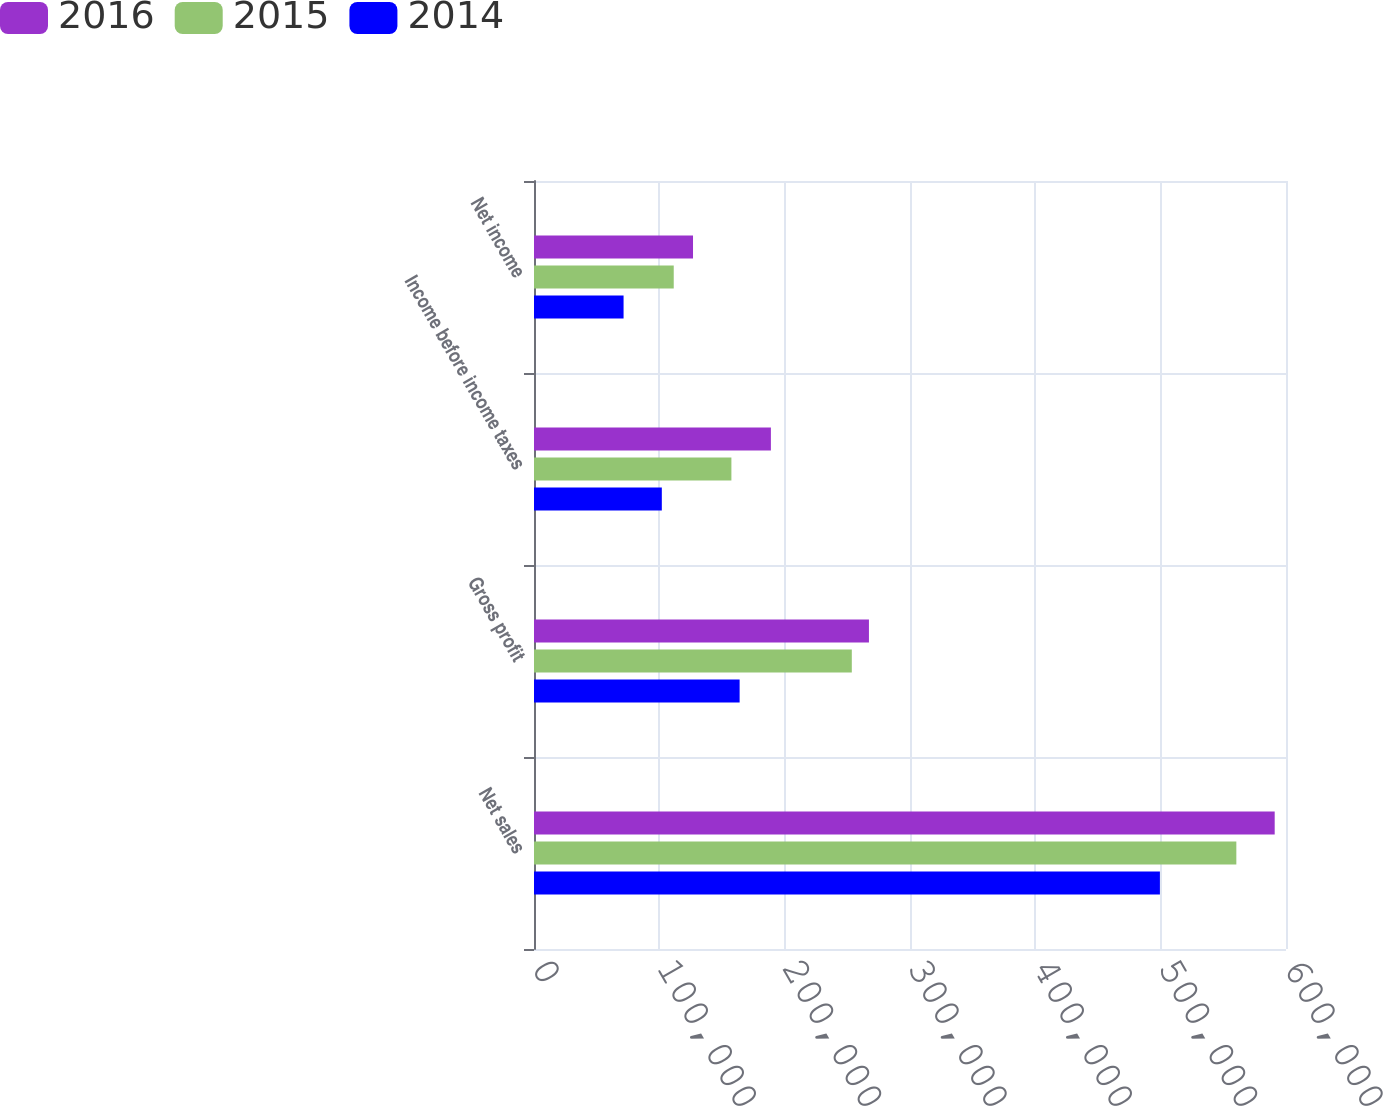<chart> <loc_0><loc_0><loc_500><loc_500><stacked_bar_chart><ecel><fcel>Net sales<fcel>Gross profit<fcel>Income before income taxes<fcel>Net income<nl><fcel>2016<fcel>590980<fcel>267241<fcel>189016<fcel>126872<nl><fcel>2015<fcel>560376<fcel>253569<fcel>157501<fcel>111491<nl><fcel>2014<fcel>499394<fcel>164063<fcel>101983<fcel>71466<nl></chart> 